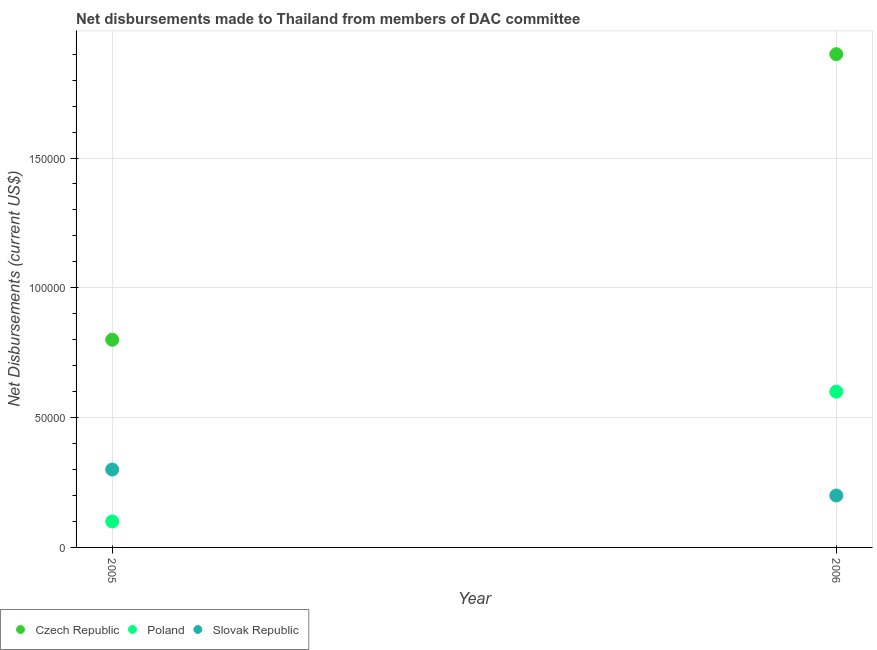How many different coloured dotlines are there?
Your answer should be very brief. 3. What is the net disbursements made by poland in 2005?
Provide a succinct answer. 10000. Across all years, what is the maximum net disbursements made by slovak republic?
Offer a very short reply. 3.00e+04. Across all years, what is the minimum net disbursements made by czech republic?
Give a very brief answer. 8.00e+04. In which year was the net disbursements made by poland maximum?
Offer a very short reply. 2006. In which year was the net disbursements made by czech republic minimum?
Offer a very short reply. 2005. What is the total net disbursements made by czech republic in the graph?
Your response must be concise. 2.70e+05. What is the difference between the net disbursements made by poland in 2005 and that in 2006?
Make the answer very short. -5.00e+04. What is the difference between the net disbursements made by slovak republic in 2006 and the net disbursements made by czech republic in 2005?
Make the answer very short. -6.00e+04. What is the average net disbursements made by slovak republic per year?
Offer a very short reply. 2.50e+04. In the year 2006, what is the difference between the net disbursements made by poland and net disbursements made by czech republic?
Your answer should be compact. -1.30e+05. Does the net disbursements made by czech republic monotonically increase over the years?
Offer a very short reply. Yes. How many dotlines are there?
Your answer should be compact. 3. How many years are there in the graph?
Provide a succinct answer. 2. What is the difference between two consecutive major ticks on the Y-axis?
Ensure brevity in your answer.  5.00e+04. Does the graph contain grids?
Give a very brief answer. Yes. Where does the legend appear in the graph?
Your response must be concise. Bottom left. How many legend labels are there?
Your response must be concise. 3. What is the title of the graph?
Provide a short and direct response. Net disbursements made to Thailand from members of DAC committee. What is the label or title of the X-axis?
Your answer should be compact. Year. What is the label or title of the Y-axis?
Offer a very short reply. Net Disbursements (current US$). What is the Net Disbursements (current US$) of Slovak Republic in 2005?
Your answer should be very brief. 3.00e+04. What is the Net Disbursements (current US$) in Slovak Republic in 2006?
Ensure brevity in your answer.  2.00e+04. Across all years, what is the maximum Net Disbursements (current US$) in Czech Republic?
Your answer should be very brief. 1.90e+05. Across all years, what is the maximum Net Disbursements (current US$) in Poland?
Your answer should be compact. 6.00e+04. Across all years, what is the maximum Net Disbursements (current US$) of Slovak Republic?
Your response must be concise. 3.00e+04. Across all years, what is the minimum Net Disbursements (current US$) of Poland?
Provide a succinct answer. 10000. Across all years, what is the minimum Net Disbursements (current US$) of Slovak Republic?
Give a very brief answer. 2.00e+04. What is the total Net Disbursements (current US$) of Czech Republic in the graph?
Ensure brevity in your answer.  2.70e+05. What is the total Net Disbursements (current US$) in Poland in the graph?
Offer a very short reply. 7.00e+04. What is the total Net Disbursements (current US$) of Slovak Republic in the graph?
Offer a very short reply. 5.00e+04. What is the difference between the Net Disbursements (current US$) in Poland in 2005 and that in 2006?
Make the answer very short. -5.00e+04. What is the difference between the Net Disbursements (current US$) of Slovak Republic in 2005 and that in 2006?
Make the answer very short. 10000. What is the difference between the Net Disbursements (current US$) of Czech Republic in 2005 and the Net Disbursements (current US$) of Slovak Republic in 2006?
Offer a very short reply. 6.00e+04. What is the average Net Disbursements (current US$) of Czech Republic per year?
Ensure brevity in your answer.  1.35e+05. What is the average Net Disbursements (current US$) in Poland per year?
Provide a short and direct response. 3.50e+04. What is the average Net Disbursements (current US$) in Slovak Republic per year?
Your response must be concise. 2.50e+04. In the year 2005, what is the difference between the Net Disbursements (current US$) in Czech Republic and Net Disbursements (current US$) in Slovak Republic?
Keep it short and to the point. 5.00e+04. In the year 2006, what is the difference between the Net Disbursements (current US$) of Czech Republic and Net Disbursements (current US$) of Poland?
Offer a terse response. 1.30e+05. What is the ratio of the Net Disbursements (current US$) in Czech Republic in 2005 to that in 2006?
Provide a succinct answer. 0.42. What is the ratio of the Net Disbursements (current US$) in Poland in 2005 to that in 2006?
Provide a short and direct response. 0.17. What is the ratio of the Net Disbursements (current US$) of Slovak Republic in 2005 to that in 2006?
Keep it short and to the point. 1.5. What is the difference between the highest and the second highest Net Disbursements (current US$) in Slovak Republic?
Offer a very short reply. 10000. What is the difference between the highest and the lowest Net Disbursements (current US$) in Poland?
Provide a succinct answer. 5.00e+04. 